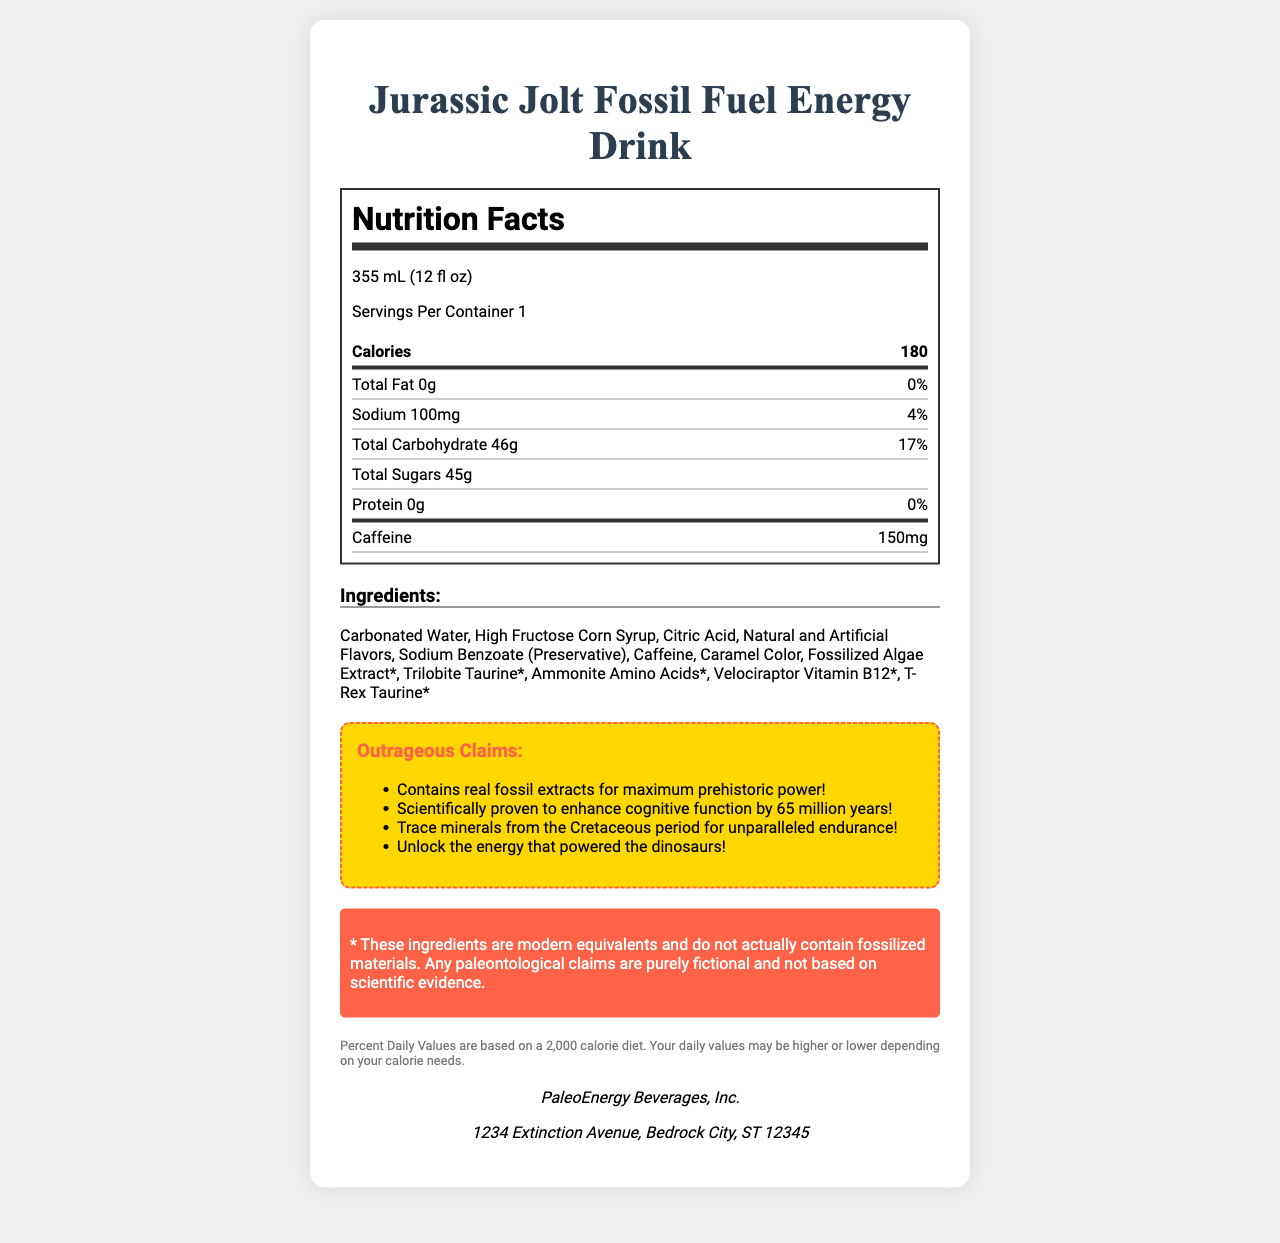what is the product name? The product name is clearly stated at the top of the document in the title.
Answer: Jurassic Jolt Fossil Fuel Energy Drink what is the serving size? The serving size is mentioned right below the product name and is described as 355 mL (12 fl oz).
Answer: 355 mL (12 fl oz) how many calories are in one serving? The document shows the calorie count as 180 in the first thick-bottom row under the Nutrition Facts section.
Answer: 180 how much caffeine does one serving contain? The amount of caffeine is specified in the final row underneath the nutrition information.
Answer: 150 mg what ingredients are listed in the drink? The ingredients are mentioned under the "Ingredients" section in the document.
Answer: Carbonated Water, High Fructose Corn Syrup, Citric Acid, Natural and Artificial Flavors, Sodium Benzoate (Preservative), Caffeine, Caramel Color, Fossilized Algae Extract*, Trilobite Taurine*, Ammonite Amino Acids*, Velociraptor Vitamin B12*, T-Rex Taurine* which company manufactures the drink? A. CaveEnergy, Inc. B. PaleoEnergy Beverages, Inc. C. DinoDrinks Co. D. Prehistoric Power Ltd. The company name, PaleoEnergy Beverages, Inc., is provided at the bottom of the document under the manufacturer section.
Answer: B what is the sodium percentage daily value per serving? A. 1% B. 2% C. 4% D. 8% The sodium percentage daily value is given as 4% in the second row of the nutrition information.
Answer: C Is it true that the drink contains real fossil extracts? The warning section specifies that the ingredients do not actually contain fossilized materials and that any paleontological claims are purely fictional.
Answer: No summarize the main idea of the document. The document combines nutritional facts and humorous fictional claims about prehistoric energy, explicitly warning consumers about the fictional nature of these claims while listing out the actual nutritional content and ingredients.
Answer: The Jurassic Jolt Fossil Fuel Energy Drink is advertised with various humorous and misleading claims about prehistoric power. It provides nutritional information including calories, total fat, sodium, carbohydrates, sugars, protein, and caffeine, and lists the ingredients used. The document explicitly states that fossil-related ingredients and claims are fictional and includes the manufacturer's details. how many grams of total sugar are in one serving? The document specifies the total sugars content as 45g in one serving under the Total Sugars section.
Answer: 45g what are the outrageous claims mentioned in the document? These claims are listed under the "Outrageous Claims" section, highlighted in a dashed box.
Answer: The claims are: "Contains real fossil extracts for maximum prehistoric power!", "Scientifically proven to enhance cognitive function by 65 million years!", "Trace minerals from the Cretaceous period for unparalleled endurance!", "Unlock the energy that powered the dinosaurs!" which ingredient is specifically mentioned as a preservative? Sodium Benzoate is noted as a preservative in the ingredient list.
Answer: Sodium Benzoate what is the physical address of the manufacturer? The manufacturer's address is provided at the bottom of the document under the manufacturer details.
Answer: 1234 Extinction Avenue, Bedrock City, ST 12345 what percentage of the daily value for carbohydrates does one serving contain? The percentage daily value for total carbohydrates per serving is listed as 17% in the nutrition information section.
Answer: 17% is there any protein in this energy drink? The document mentions that the protein content is 0g and the percent daily value is 0%.
Answer: No how effective is the drink in enhancing cognitive function? The document includes a humorous and misleading claim that the drink enhances cognitive function by 65 million years, which is clearly fictional. The warning section states these claims are not based on scientific evidence.
Answer: Cannot be determined 